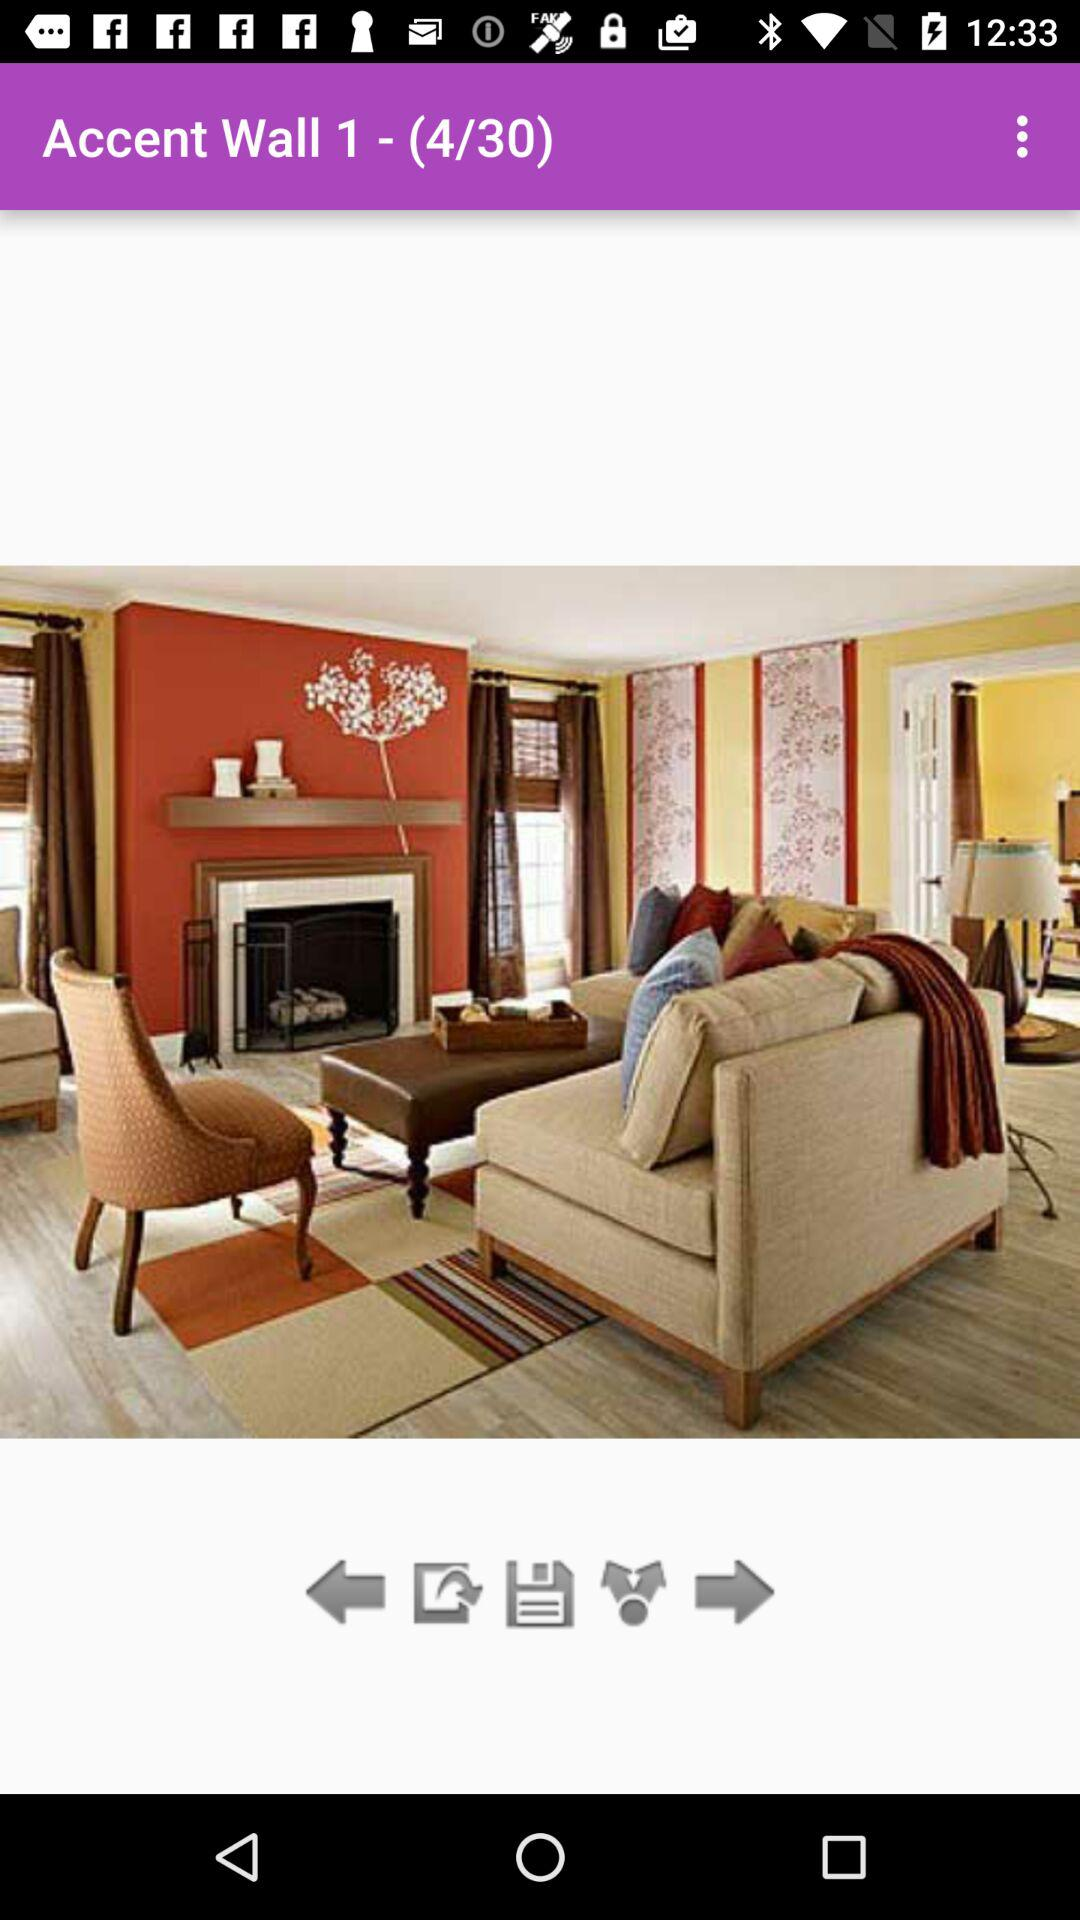How many total photos are there? There are 30 photos in total. 